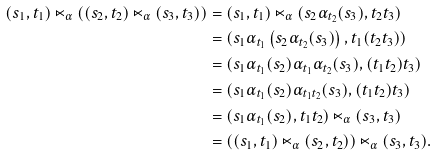Convert formula to latex. <formula><loc_0><loc_0><loc_500><loc_500>( s _ { 1 } , t _ { 1 } ) \ltimes _ { \alpha } \left ( ( s _ { 2 } , t _ { 2 } ) \ltimes _ { \alpha } ( s _ { 3 } , t _ { 3 } ) \right ) & = ( s _ { 1 } , t _ { 1 } ) \ltimes _ { \alpha } ( s _ { 2 } \alpha _ { t _ { 2 } } ( s _ { 3 } ) , t _ { 2 } t _ { 3 } ) \\ & = ( s _ { 1 } \alpha _ { t _ { 1 } } \left ( s _ { 2 } \alpha _ { t _ { 2 } } ( s _ { 3 } ) \right ) , t _ { 1 } ( t _ { 2 } t _ { 3 } ) ) \\ & = ( s _ { 1 } \alpha _ { t _ { 1 } } ( s _ { 2 } ) \alpha _ { t _ { 1 } } \alpha _ { t _ { 2 } } ( s _ { 3 } ) , ( t _ { 1 } t _ { 2 } ) t _ { 3 } ) \\ & = ( s _ { 1 } \alpha _ { t _ { 1 } } ( s _ { 2 } ) \alpha _ { t _ { 1 } t _ { 2 } } ( s _ { 3 } ) , ( t _ { 1 } t _ { 2 } ) t _ { 3 } ) \\ & = ( s _ { 1 } \alpha _ { t _ { 1 } } ( s _ { 2 } ) , t _ { 1 } t _ { 2 } ) \ltimes _ { \alpha } ( s _ { 3 } , t _ { 3 } ) \\ & = \left ( ( s _ { 1 } , t _ { 1 } ) \ltimes _ { \alpha } ( s _ { 2 } , t _ { 2 } ) \right ) \ltimes _ { \alpha } ( s _ { 3 } , t _ { 3 } ) .</formula> 